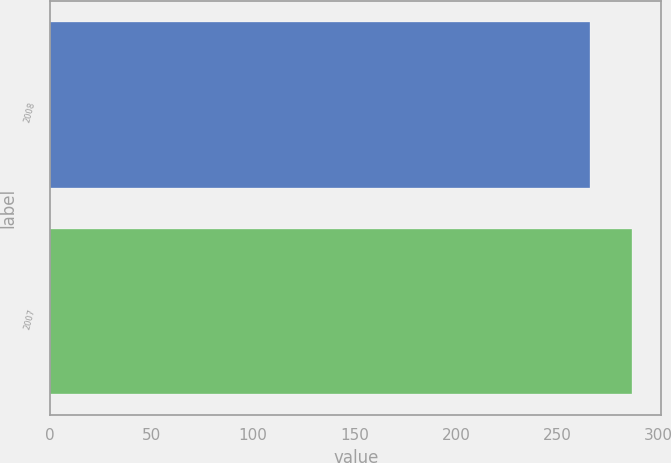Convert chart. <chart><loc_0><loc_0><loc_500><loc_500><bar_chart><fcel>2008<fcel>2007<nl><fcel>266<fcel>287<nl></chart> 